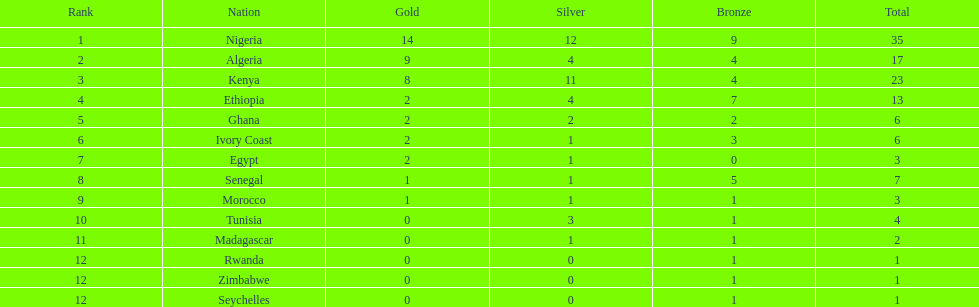In which country were the most medals won? Nigeria. 